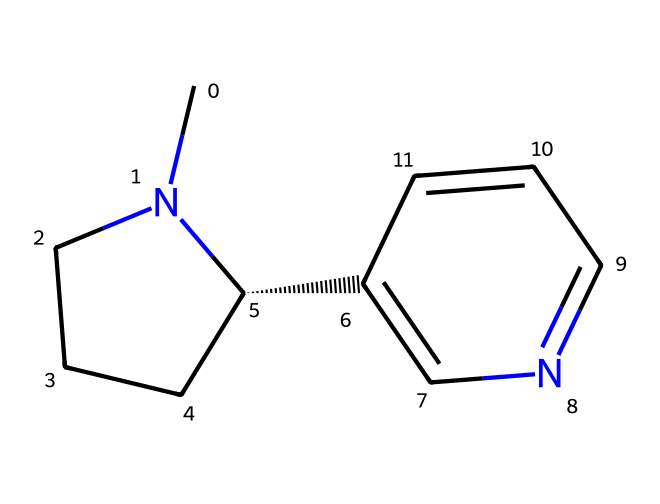What is the name of this chemical? The SMILES representation corresponds to nicotine, a well-known alkaloid found in tobacco products.
Answer: nicotine How many nitrogen atoms are present in this structure? By analyzing the SMILES, it is clear that there are two nitrogen atoms indicated by the symbols "N" in the structure.
Answer: 2 What is the total number of carbon atoms in this compound? The SMILES representation shows seven carbon atoms (C) by counting each occurrence of "C" in the structure.
Answer: 10 Does this compound contain any double bonds? The SMILES representation includes a double bond indicated by the "=" symbol between carbon and nitrogen, confirming the presence of double bonds in the structure.
Answer: yes Identify the type of carbon chain in nicotine. Nicotine has a cyclic structure, indicated by the numeric notation "1" in the SMILES which signifies that there is a ring involved in its structure.
Answer: cyclic What functional groups can be found in nicotine? The structure of nicotine showcases only nitrogen atoms as functional groups, primarily indicating it is an alkaloid; no other specific functional groups are prominent.
Answer: nitrogen Does nicotine belong to aliphatic or aromatic compounds? Analyzing the structure shows that while nicotine has some aromatic characteristics, it primarily is classified as an aliphatic compound due to the presence of long carbon chains with single bonds.
Answer: aliphatic 